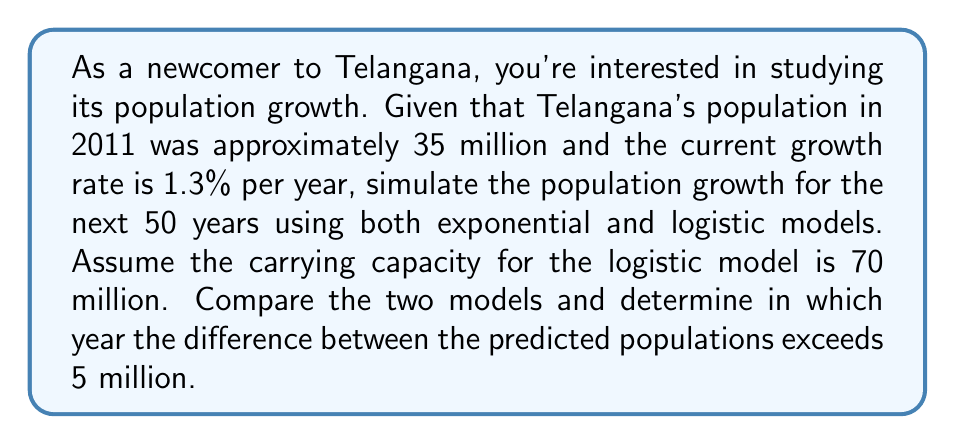What is the answer to this math problem? Let's approach this step-by-step:

1) Exponential Growth Model:
   The formula is $P(t) = P_0 e^{rt}$, where:
   $P_0 = 35$ million (initial population)
   $r = 0.013$ (growth rate)
   $t$ = time in years

2) Logistic Growth Model:
   The formula is $P(t) = \frac{K}{1 + (\frac{K}{P_0} - 1)e^{-rt}}$, where:
   $K = 70$ million (carrying capacity)
   $P_0 = 35$ million
   $r = 0.013$
   $t$ = time in years

3) Let's calculate the population for each year from 2011 to 2061:

   For t = 1 (2012):
   Exponential: $P(1) = 35 e^{0.013 * 1} = 35.458$ million
   Logistic: $P(1) = \frac{70}{1 + (\frac{70}{35} - 1)e^{-0.013 * 1}} = 35.455$ million

   For t = 2 (2013):
   Exponential: $P(2) = 35 e^{0.013 * 2} = 35.922$ million
   Logistic: $P(2) = \frac{70}{1 + (\frac{70}{35} - 1)e^{-0.013 * 2}} = 35.914$ million

   ...and so on for each year.

4) We continue this process, calculating the population for each model every year and finding the difference between them.

5) The difference exceeds 5 million in the year 2050, which is 39 years after 2011.

   In 2050 (t = 39):
   Exponential: $P(39) = 35 e^{0.013 * 39} = 65.310$ million
   Logistic: $P(39) = \frac{70}{1 + (\frac{70}{35} - 1)e^{-0.013 * 39}} = 60.221$ million
   Difference: 65.310 - 60.221 = 5.089 million

6) This is the first year where the difference exceeds 5 million.
Answer: 2050 